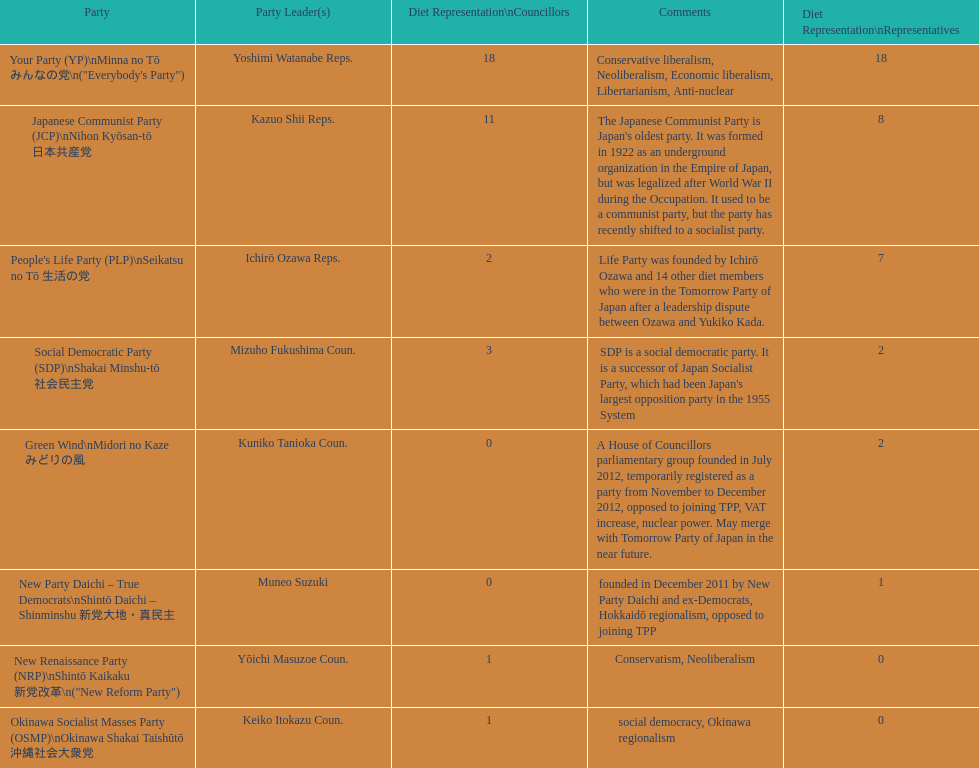What party is listed previous to the new renaissance party? New Party Daichi - True Democrats. 